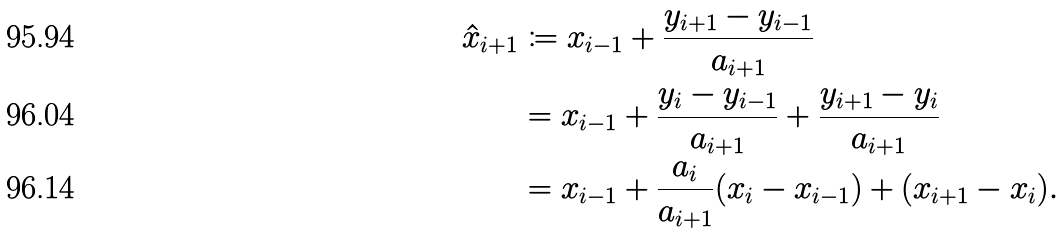<formula> <loc_0><loc_0><loc_500><loc_500>\hat { x } _ { i + 1 } & \coloneqq x _ { i - 1 } + \frac { y _ { i + 1 } - y _ { i - 1 } } { a _ { i + 1 } } \\ & = x _ { i - 1 } + \frac { y _ { i } - y _ { i - 1 } } { a _ { i + 1 } } + \frac { y _ { i + 1 } - y _ { i } } { a _ { i + 1 } } \\ & = x _ { i - 1 } + \frac { a _ { i } } { a _ { i + 1 } } ( x _ { i } - x _ { i - 1 } ) + ( x _ { i + 1 } - x _ { i } ) .</formula> 